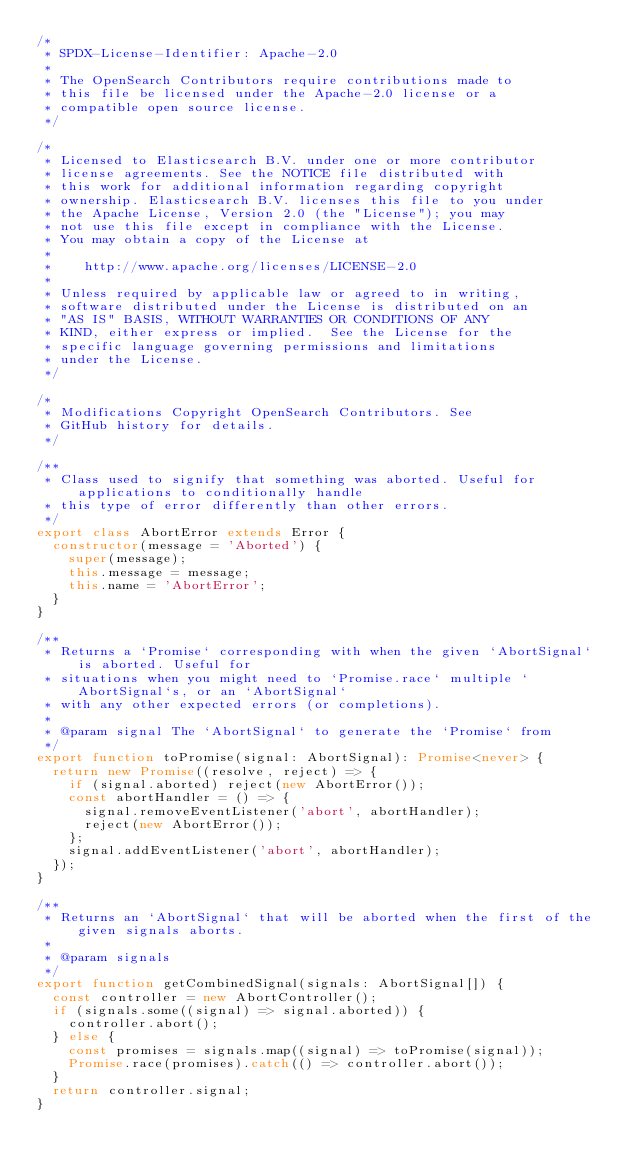Convert code to text. <code><loc_0><loc_0><loc_500><loc_500><_TypeScript_>/*
 * SPDX-License-Identifier: Apache-2.0
 *
 * The OpenSearch Contributors require contributions made to
 * this file be licensed under the Apache-2.0 license or a
 * compatible open source license.
 */

/*
 * Licensed to Elasticsearch B.V. under one or more contributor
 * license agreements. See the NOTICE file distributed with
 * this work for additional information regarding copyright
 * ownership. Elasticsearch B.V. licenses this file to you under
 * the Apache License, Version 2.0 (the "License"); you may
 * not use this file except in compliance with the License.
 * You may obtain a copy of the License at
 *
 *    http://www.apache.org/licenses/LICENSE-2.0
 *
 * Unless required by applicable law or agreed to in writing,
 * software distributed under the License is distributed on an
 * "AS IS" BASIS, WITHOUT WARRANTIES OR CONDITIONS OF ANY
 * KIND, either express or implied.  See the License for the
 * specific language governing permissions and limitations
 * under the License.
 */

/*
 * Modifications Copyright OpenSearch Contributors. See
 * GitHub history for details.
 */

/**
 * Class used to signify that something was aborted. Useful for applications to conditionally handle
 * this type of error differently than other errors.
 */
export class AbortError extends Error {
  constructor(message = 'Aborted') {
    super(message);
    this.message = message;
    this.name = 'AbortError';
  }
}

/**
 * Returns a `Promise` corresponding with when the given `AbortSignal` is aborted. Useful for
 * situations when you might need to `Promise.race` multiple `AbortSignal`s, or an `AbortSignal`
 * with any other expected errors (or completions).
 *
 * @param signal The `AbortSignal` to generate the `Promise` from
 */
export function toPromise(signal: AbortSignal): Promise<never> {
  return new Promise((resolve, reject) => {
    if (signal.aborted) reject(new AbortError());
    const abortHandler = () => {
      signal.removeEventListener('abort', abortHandler);
      reject(new AbortError());
    };
    signal.addEventListener('abort', abortHandler);
  });
}

/**
 * Returns an `AbortSignal` that will be aborted when the first of the given signals aborts.
 *
 * @param signals
 */
export function getCombinedSignal(signals: AbortSignal[]) {
  const controller = new AbortController();
  if (signals.some((signal) => signal.aborted)) {
    controller.abort();
  } else {
    const promises = signals.map((signal) => toPromise(signal));
    Promise.race(promises).catch(() => controller.abort());
  }
  return controller.signal;
}
</code> 